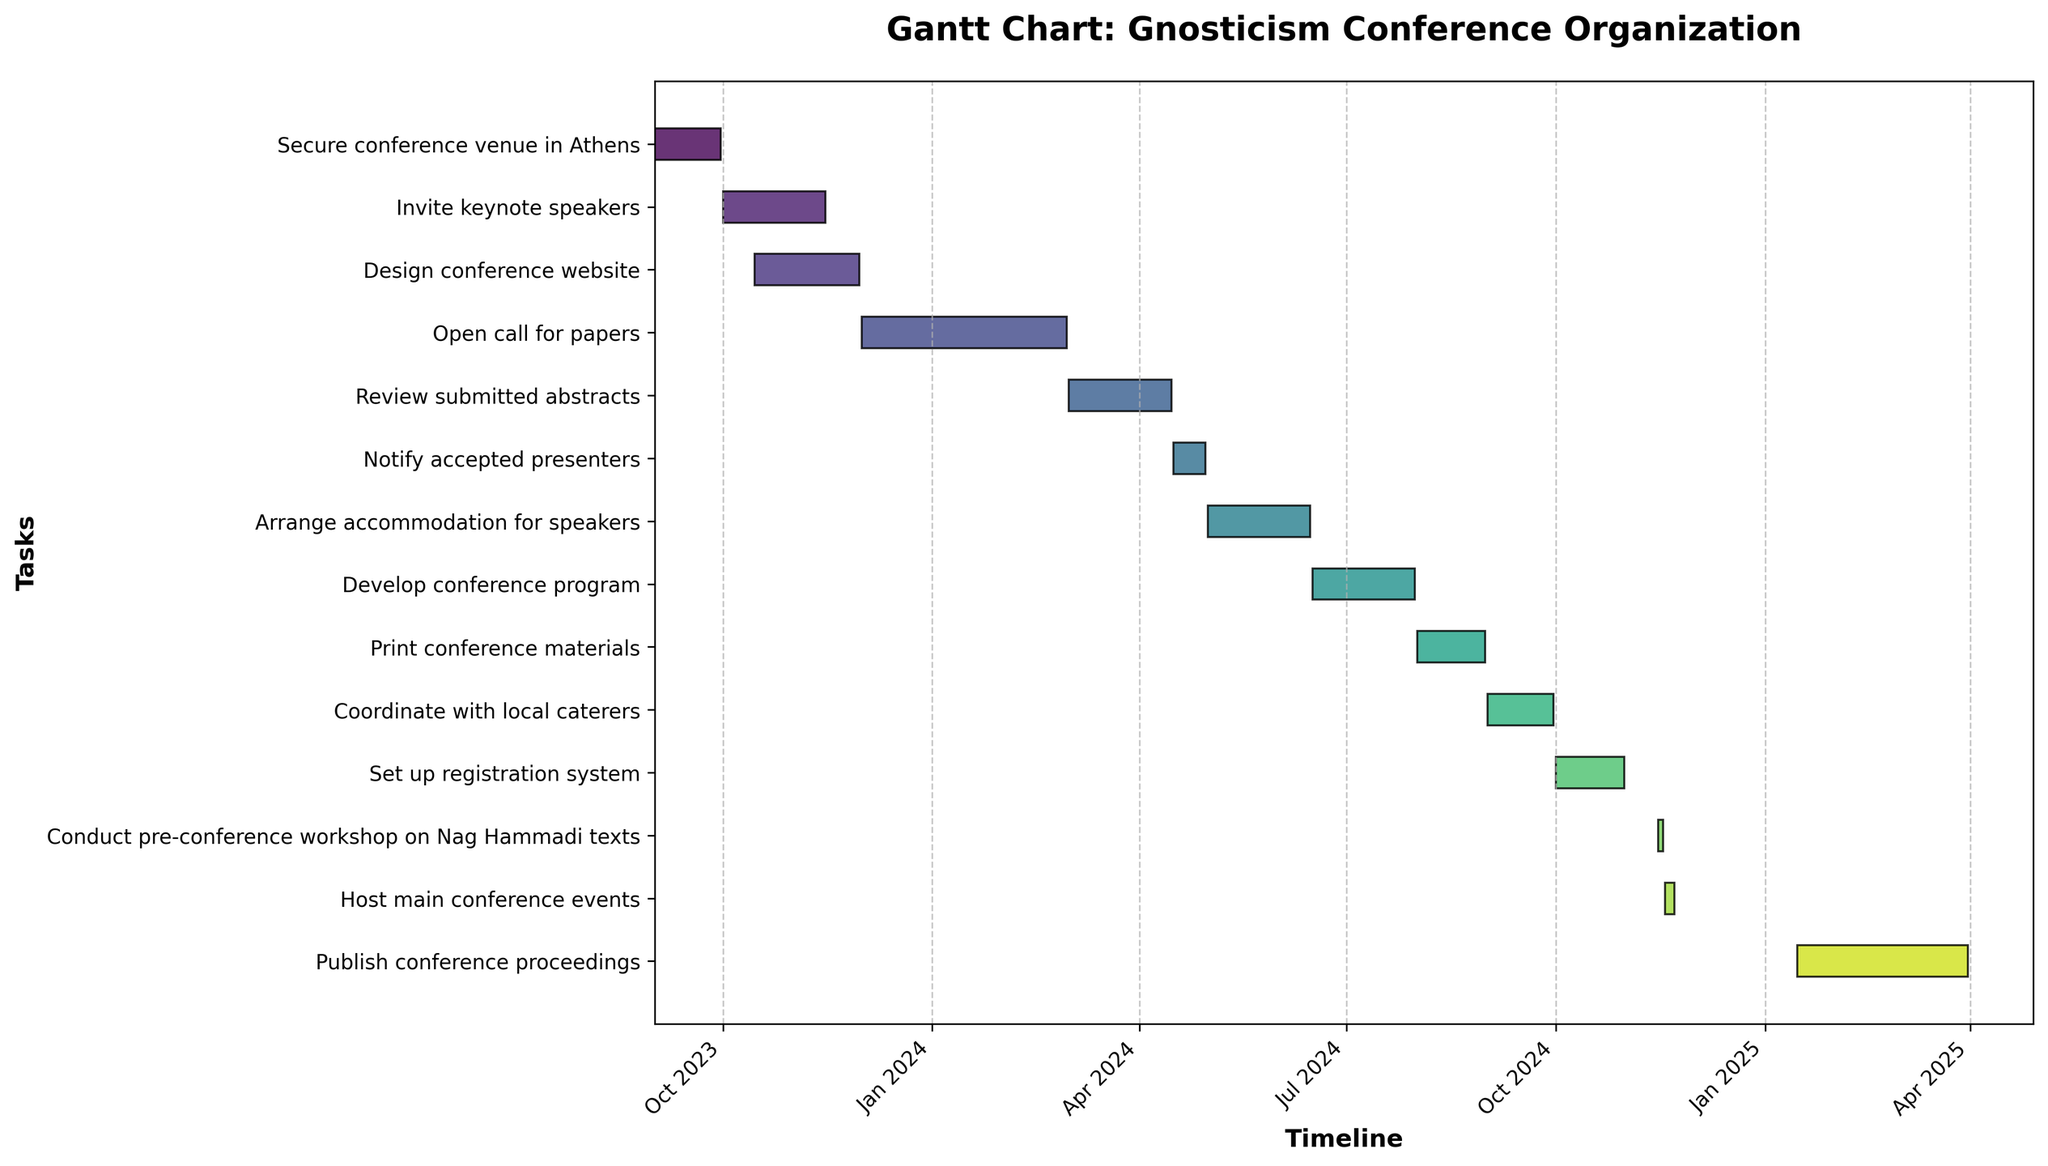When does the conference begin? The earliest task related to the main conference events starts on 2024-11-18, which marks the beginning of the actual conference.
Answer: 2024-11-18 What is the duration of the "Print conference materials" task? The task "Print conference materials" starts on 2024-08-01 and ends on 2024-08-31. The duration is the difference between these two dates.
Answer: 31 days How many days are allocated to reviewing the submitted abstracts? The task "Review submitted abstracts" starts on 2024-03-01 and ends on 2024-04-15. The duration is the difference between these two dates.
Answer: 46 days Which task ends first, "Set up registration system" or "Coordinate with local caterers"? "Coordinate with local caterers" ends on 2024-09-30, and "Set up registration system" ends on 2024-10-31. Therefore, "Coordinate with local caterers" ends first.
Answer: Coordinate with local caterers How many tasks are scheduled to be completed before 2024? The tasks "Secure conference venue in Athens," "Invite keynote speakers," and "Design conference website" are scheduled to be completed before 2024.
Answer: 3 tasks Are there any tasks that overlap with the development of the conference program? The tasks "Arrange accommodation for speakers" and "Develop conference program" both occur between 2024-06-16 and 2024-07-31, hence they overlap.
Answer: Yes What tasks start in October 2023? The tasks "Invite keynote speakers" and "Design conference website" start in October 2023.
Answer: Invite keynote speakers and Design conference website Identify the task with the shortest duration. The task with the shortest duration is "Conduct pre-conference workshop on Nag Hammadi texts," lasting only 3 days.
Answer: Conduct pre-conference workshop on Nag Hammadi texts When is the latest task completed, and what is it? The latest task to be completed is "Publish conference proceedings," which ends on 2025-03-31.
Answer: Publish conference proceedings Which task spans the longest period and how many days does it last? The task "Open call for papers" spans from 2023-12-01 to 2024-02-29, lasting 90 days, making it the longest task.
Answer: Open call for papers - 90 days 